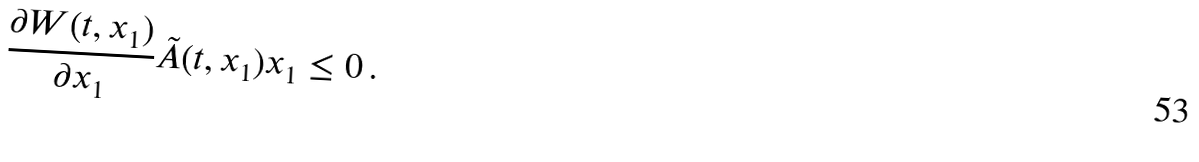<formula> <loc_0><loc_0><loc_500><loc_500>\frac { \partial W ( t , x _ { 1 } ) } { \partial x _ { 1 } } \tilde { A } ( t , x _ { 1 } ) x _ { 1 } \leq 0 \, .</formula> 